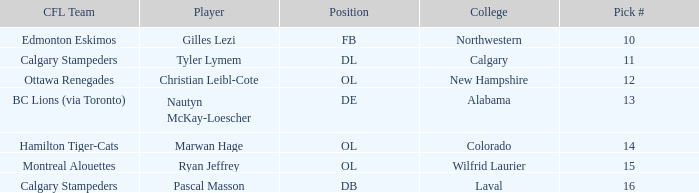Which player from the 2004 CFL draft attended Wilfrid Laurier? Ryan Jeffrey. 